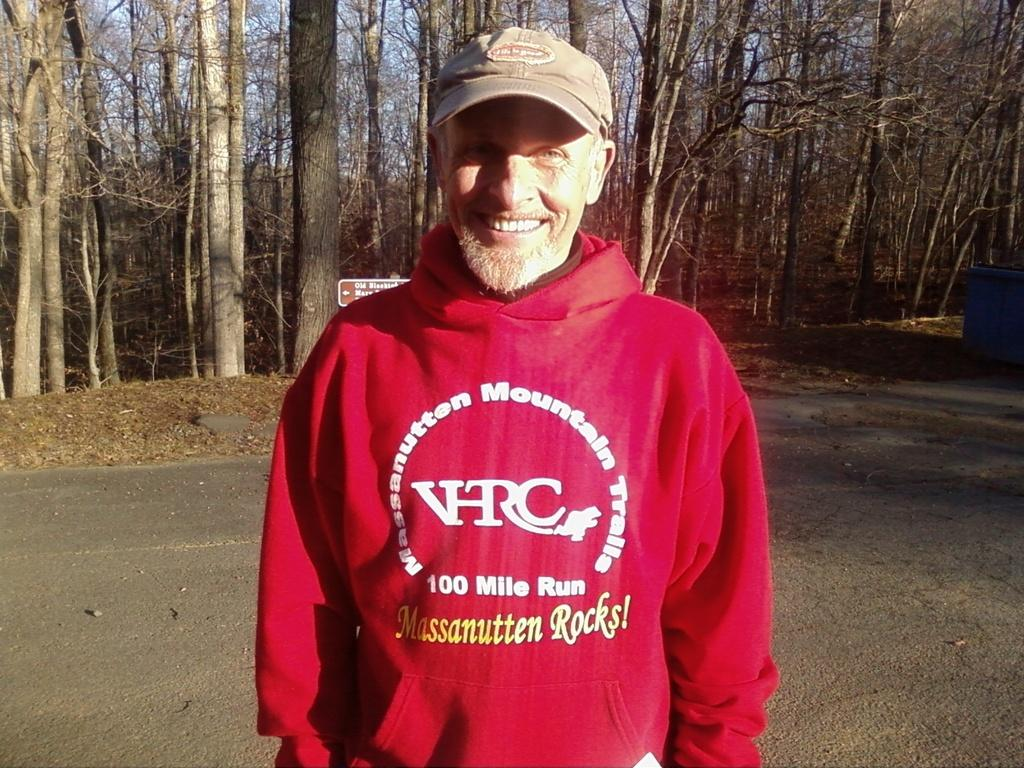<image>
Render a clear and concise summary of the photo. A man in a "100 mile run" sweatshirt smiles for the camera. 